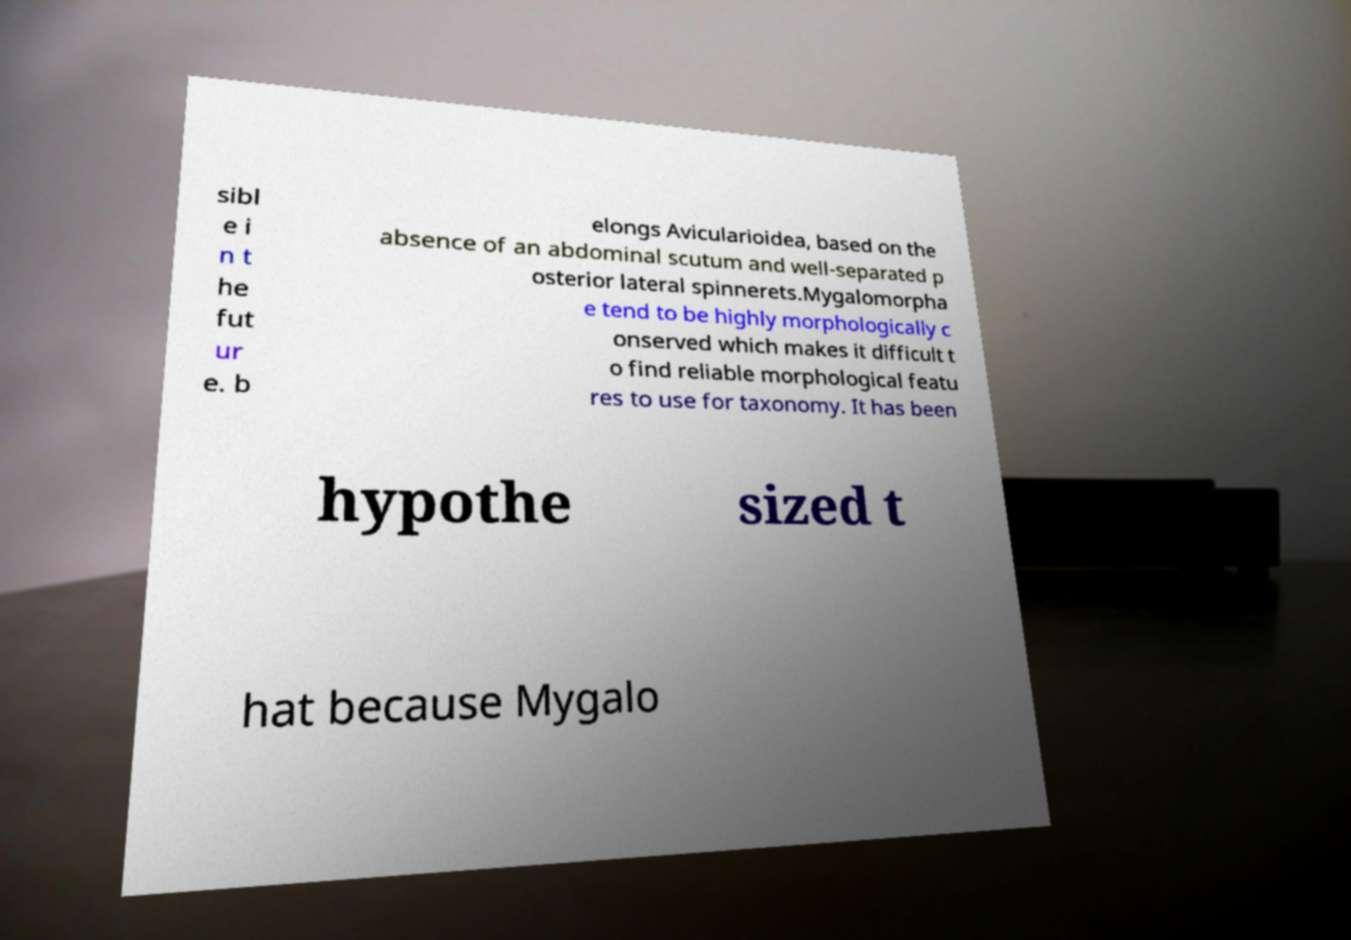Could you extract and type out the text from this image? sibl e i n t he fut ur e. b elongs Avicularioidea, based on the absence of an abdominal scutum and well-separated p osterior lateral spinnerets.Mygalomorpha e tend to be highly morphologically c onserved which makes it difficult t o find reliable morphological featu res to use for taxonomy. It has been hypothe sized t hat because Mygalo 